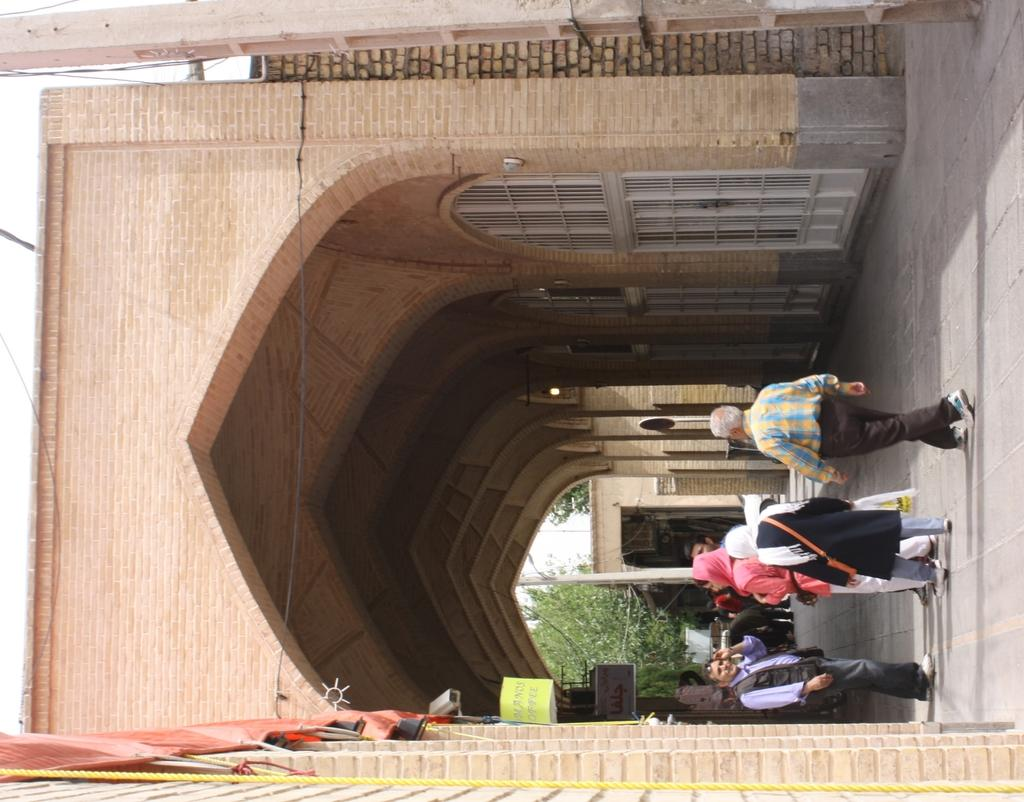What is happening on the road in the image? There are people on the road in the image. What structure can be seen in the image? There is an arch in the image. What is the level of wealth displayed by the people in the image? The level of wealth cannot be determined from the image, as there is no information about the people's financial status. What thought process can be observed in the image? There is no thought process visible in the image, as it is a still photograph and does not show any actions or expressions that would indicate a person's thoughts. 